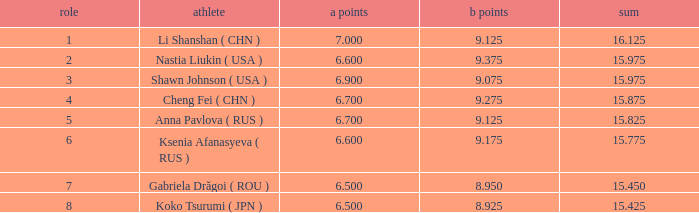What the B Score when the total is 16.125 and the position is less than 7? 9.125. Would you be able to parse every entry in this table? {'header': ['role', 'athlete', 'a points', 'b points', 'sum'], 'rows': [['1', 'Li Shanshan ( CHN )', '7.000', '9.125', '16.125'], ['2', 'Nastia Liukin ( USA )', '6.600', '9.375', '15.975'], ['3', 'Shawn Johnson ( USA )', '6.900', '9.075', '15.975'], ['4', 'Cheng Fei ( CHN )', '6.700', '9.275', '15.875'], ['5', 'Anna Pavlova ( RUS )', '6.700', '9.125', '15.825'], ['6', 'Ksenia Afanasyeva ( RUS )', '6.600', '9.175', '15.775'], ['7', 'Gabriela Drăgoi ( ROU )', '6.500', '8.950', '15.450'], ['8', 'Koko Tsurumi ( JPN )', '6.500', '8.925', '15.425']]} 